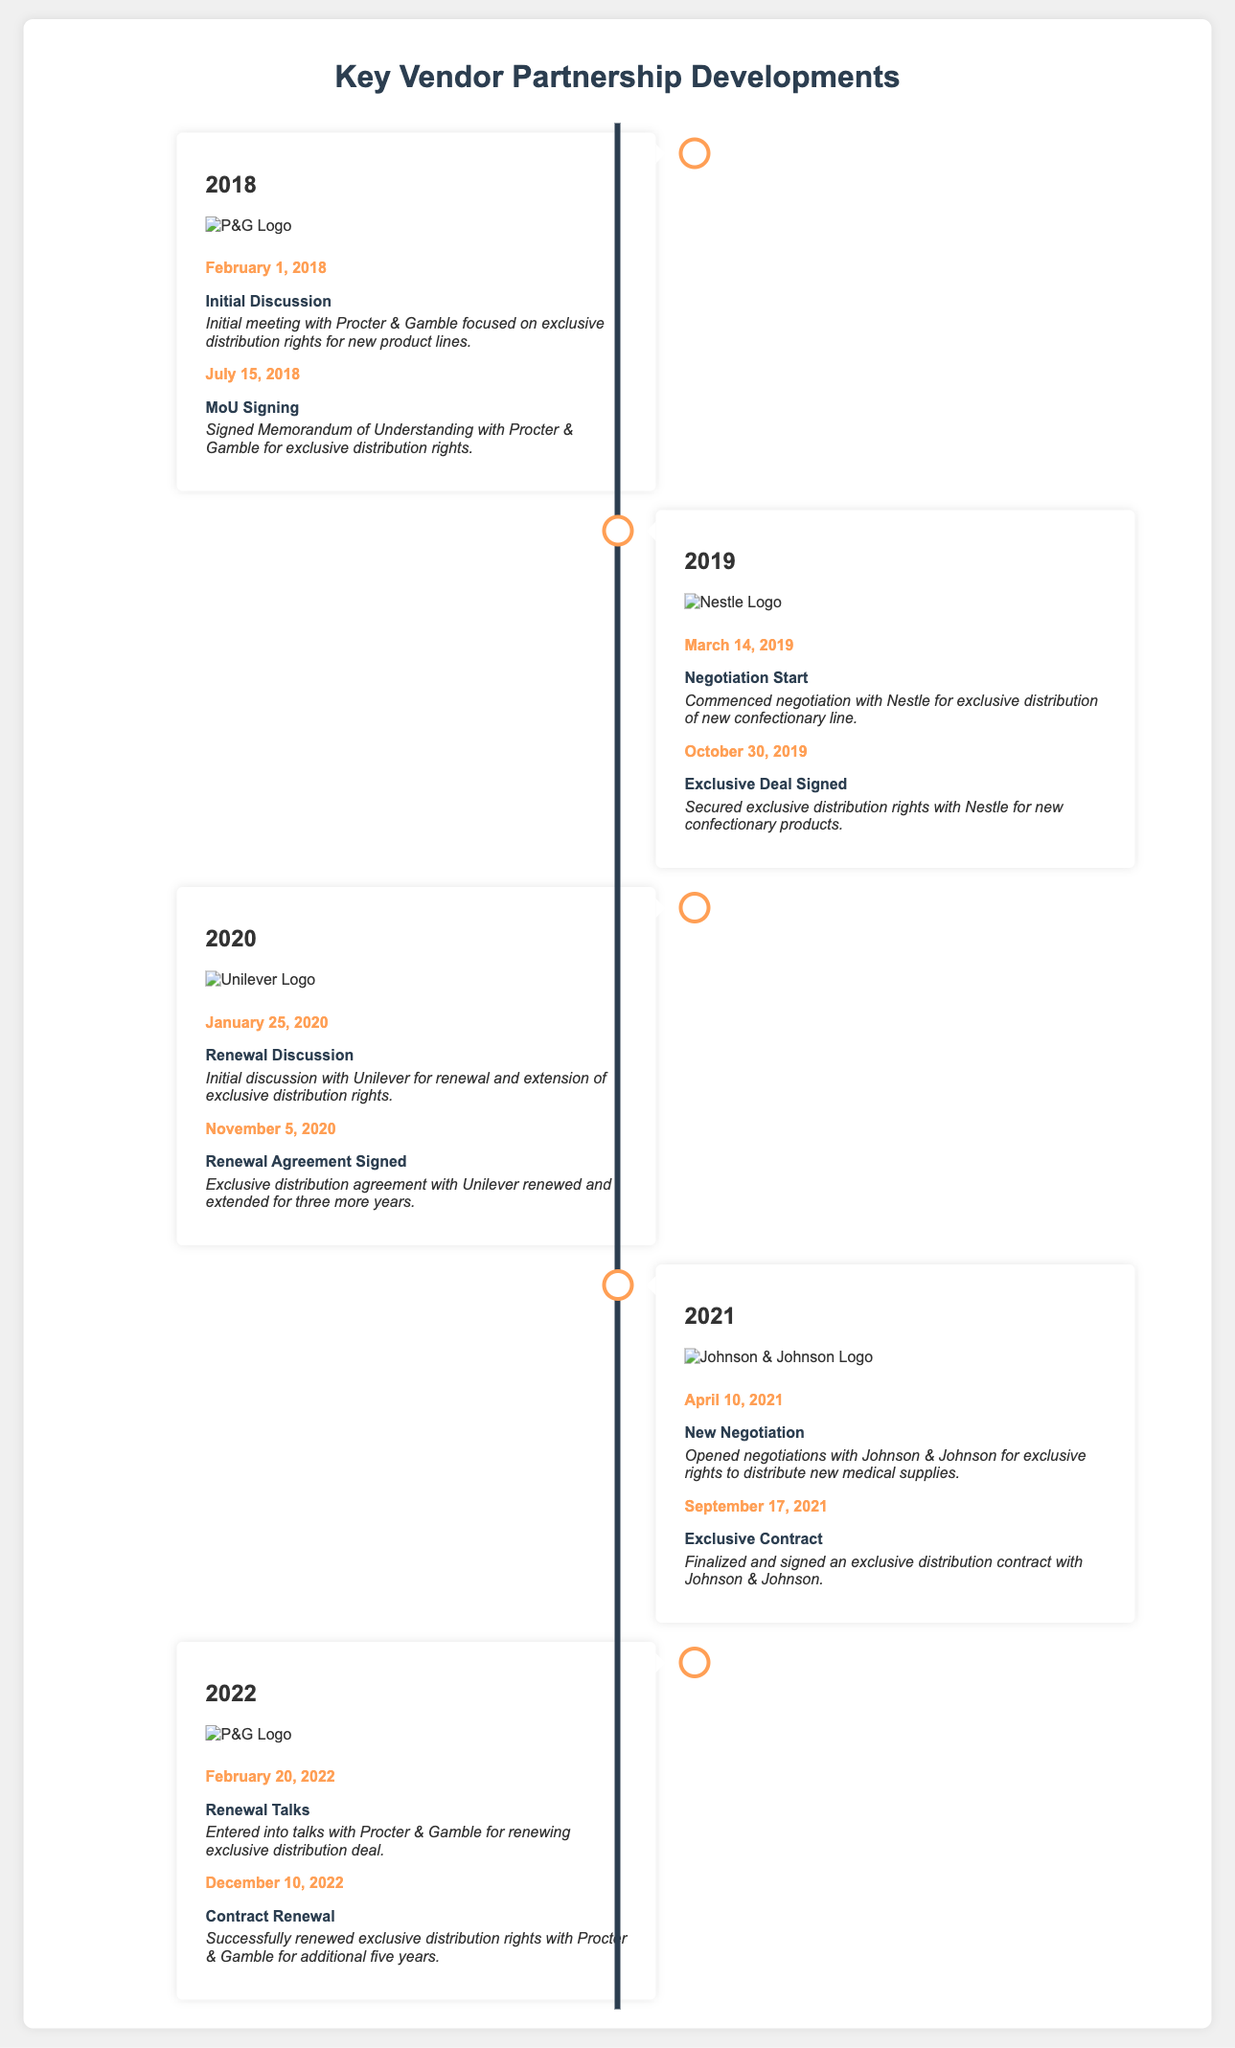What was the date of the MoU signing with Procter & Gamble? The date of the MoU signing is directly indicated in the document under the year 2018.
Answer: July 15, 2018 Which company signed an exclusive deal on October 30, 2019? The document specifies the company that signed the exclusive deal on that date under the events of the year 2019.
Answer: Nestle How many years was the exclusive distribution agreement with Unilever renewed for? The document states the renewal duration in the 2020 section of the timeline.
Answer: Three years What event occurred on February 20, 2022, with Procter & Gamble? The document details a specific event related to Procter & Gamble on that date in the year 2022.
Answer: Renewal Talks Which company did negotiations open with on April 10, 2021? The document clearly mentions the company associated with this event under the year 2021.
Answer: Johnson & Johnson What is the logo displayed for the year 2020? The logo is included in the document for the specified year, identifying the associated company.
Answer: Unilever What was the focus of the initial discussion with Procter & Gamble in 2018? The document describes the content of the initial meeting in 2018 providing insight into its purpose.
Answer: Exclusive distribution rights Which company had an event titled "Exclusive Contract" in 2021? The document notes the specific event in the timeline for the year 2021 clearly associating it with a company.
Answer: Johnson & Johnson 